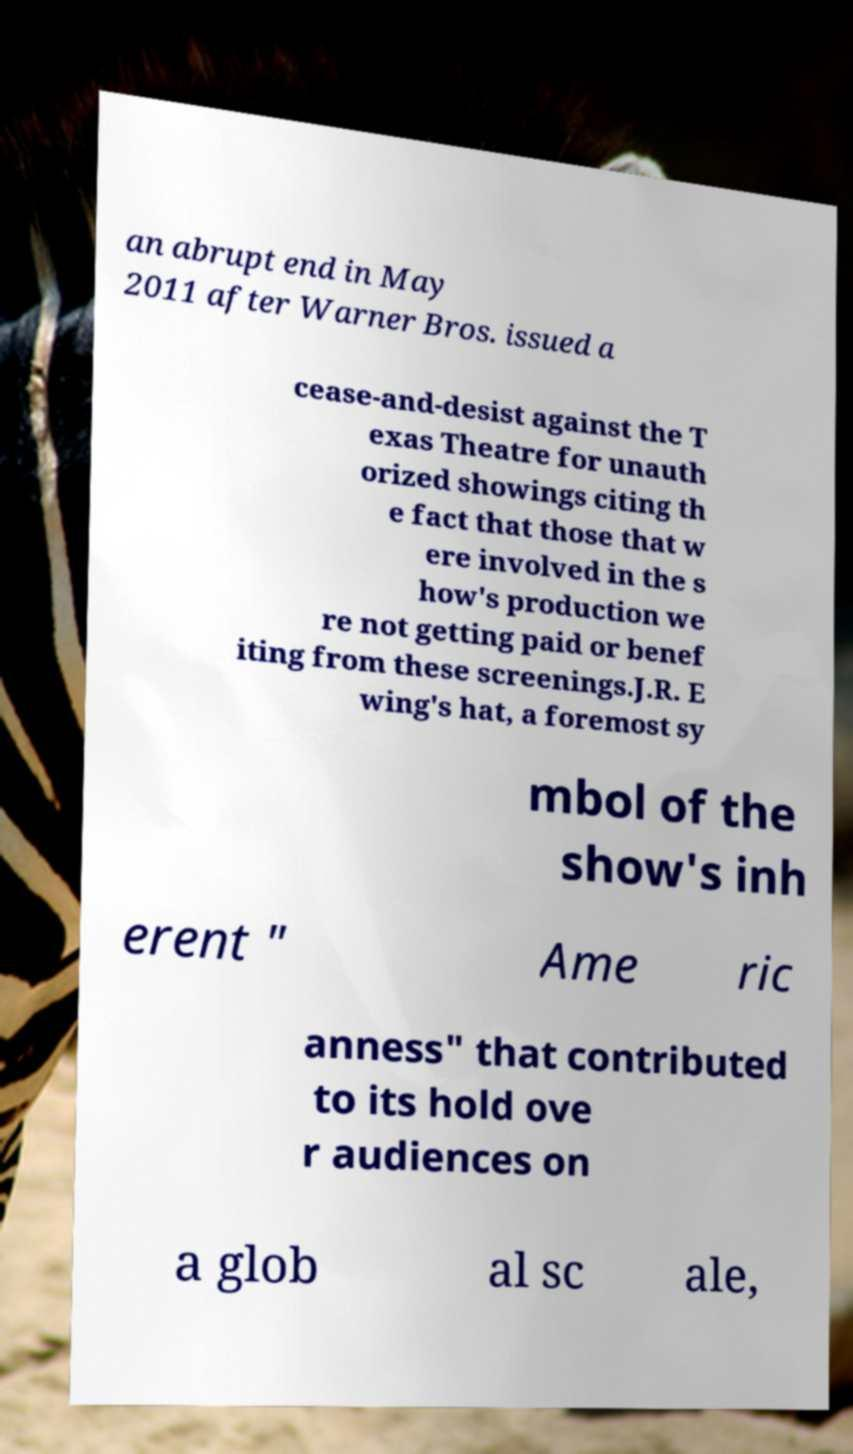For documentation purposes, I need the text within this image transcribed. Could you provide that? an abrupt end in May 2011 after Warner Bros. issued a cease-and-desist against the T exas Theatre for unauth orized showings citing th e fact that those that w ere involved in the s how's production we re not getting paid or benef iting from these screenings.J.R. E wing's hat, a foremost sy mbol of the show's inh erent " Ame ric anness" that contributed to its hold ove r audiences on a glob al sc ale, 